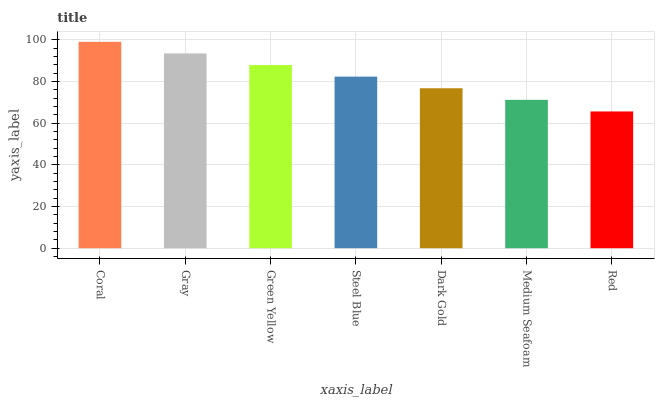Is Red the minimum?
Answer yes or no. Yes. Is Coral the maximum?
Answer yes or no. Yes. Is Gray the minimum?
Answer yes or no. No. Is Gray the maximum?
Answer yes or no. No. Is Coral greater than Gray?
Answer yes or no. Yes. Is Gray less than Coral?
Answer yes or no. Yes. Is Gray greater than Coral?
Answer yes or no. No. Is Coral less than Gray?
Answer yes or no. No. Is Steel Blue the high median?
Answer yes or no. Yes. Is Steel Blue the low median?
Answer yes or no. Yes. Is Green Yellow the high median?
Answer yes or no. No. Is Medium Seafoam the low median?
Answer yes or no. No. 